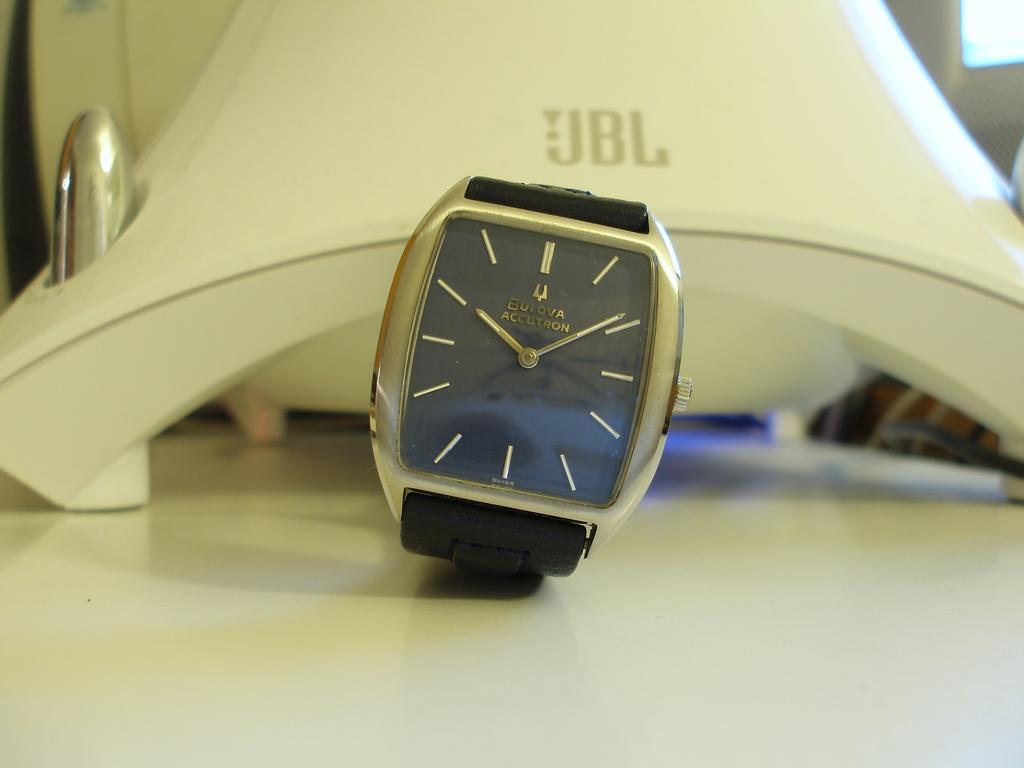What color is the watch band?
Provide a short and direct response. Answering does not require reading text in the image. What brand is the speaker behind the watch?
Offer a very short reply. Jbl. 